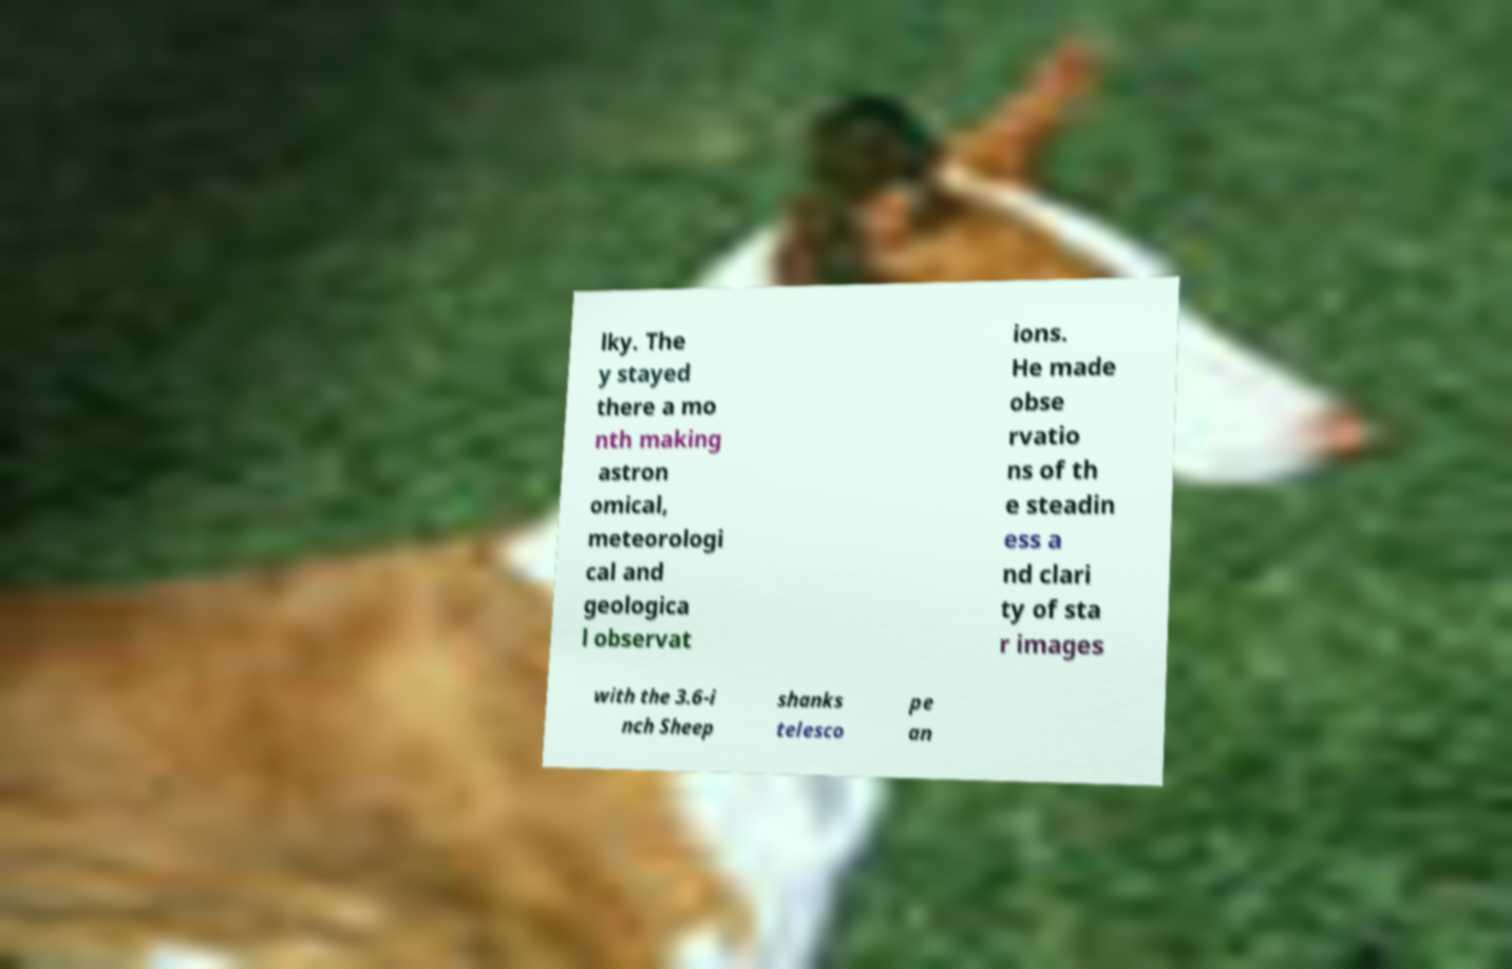Please read and relay the text visible in this image. What does it say? lky. The y stayed there a mo nth making astron omical, meteorologi cal and geologica l observat ions. He made obse rvatio ns of th e steadin ess a nd clari ty of sta r images with the 3.6-i nch Sheep shanks telesco pe an 